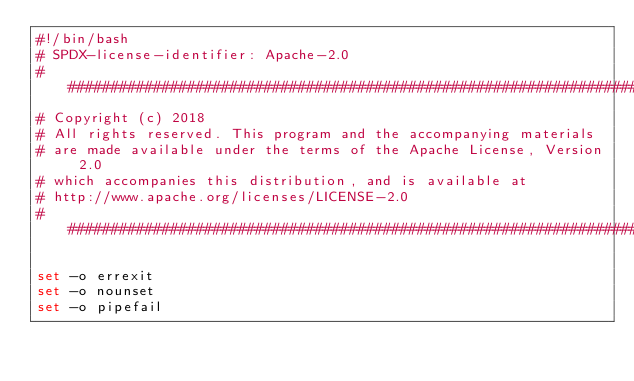<code> <loc_0><loc_0><loc_500><loc_500><_Bash_>#!/bin/bash
# SPDX-license-identifier: Apache-2.0
##############################################################################
# Copyright (c) 2018
# All rights reserved. This program and the accompanying materials
# are made available under the terms of the Apache License, Version 2.0
# which accompanies this distribution, and is available at
# http://www.apache.org/licenses/LICENSE-2.0
##############################################################################

set -o errexit
set -o nounset
set -o pipefail</code> 